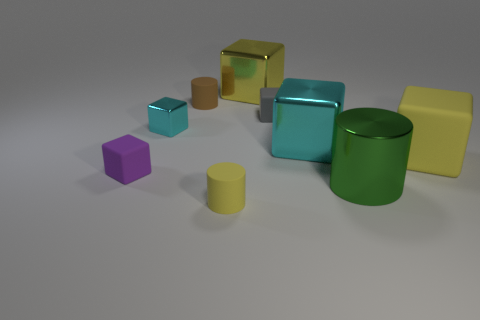The large rubber thing is what color?
Provide a succinct answer. Yellow. There is a rubber block that is in front of the gray object and behind the small purple block; what size is it?
Ensure brevity in your answer.  Large. How many things are either yellow things behind the tiny brown cylinder or cyan rubber blocks?
Offer a terse response. 1. There is a purple object that is made of the same material as the small gray cube; what is its shape?
Offer a terse response. Cube. The tiny gray matte object is what shape?
Offer a very short reply. Cube. There is a thing that is both left of the metallic cylinder and in front of the tiny purple block; what is its color?
Your response must be concise. Yellow. What shape is the gray matte object that is the same size as the brown matte object?
Your answer should be very brief. Cube. Is there a small blue thing that has the same shape as the small yellow rubber object?
Your answer should be compact. No. Are the tiny purple object and the big yellow thing in front of the brown thing made of the same material?
Provide a succinct answer. Yes. The small cylinder behind the metal object in front of the small rubber object that is to the left of the small cyan thing is what color?
Provide a short and direct response. Brown. 